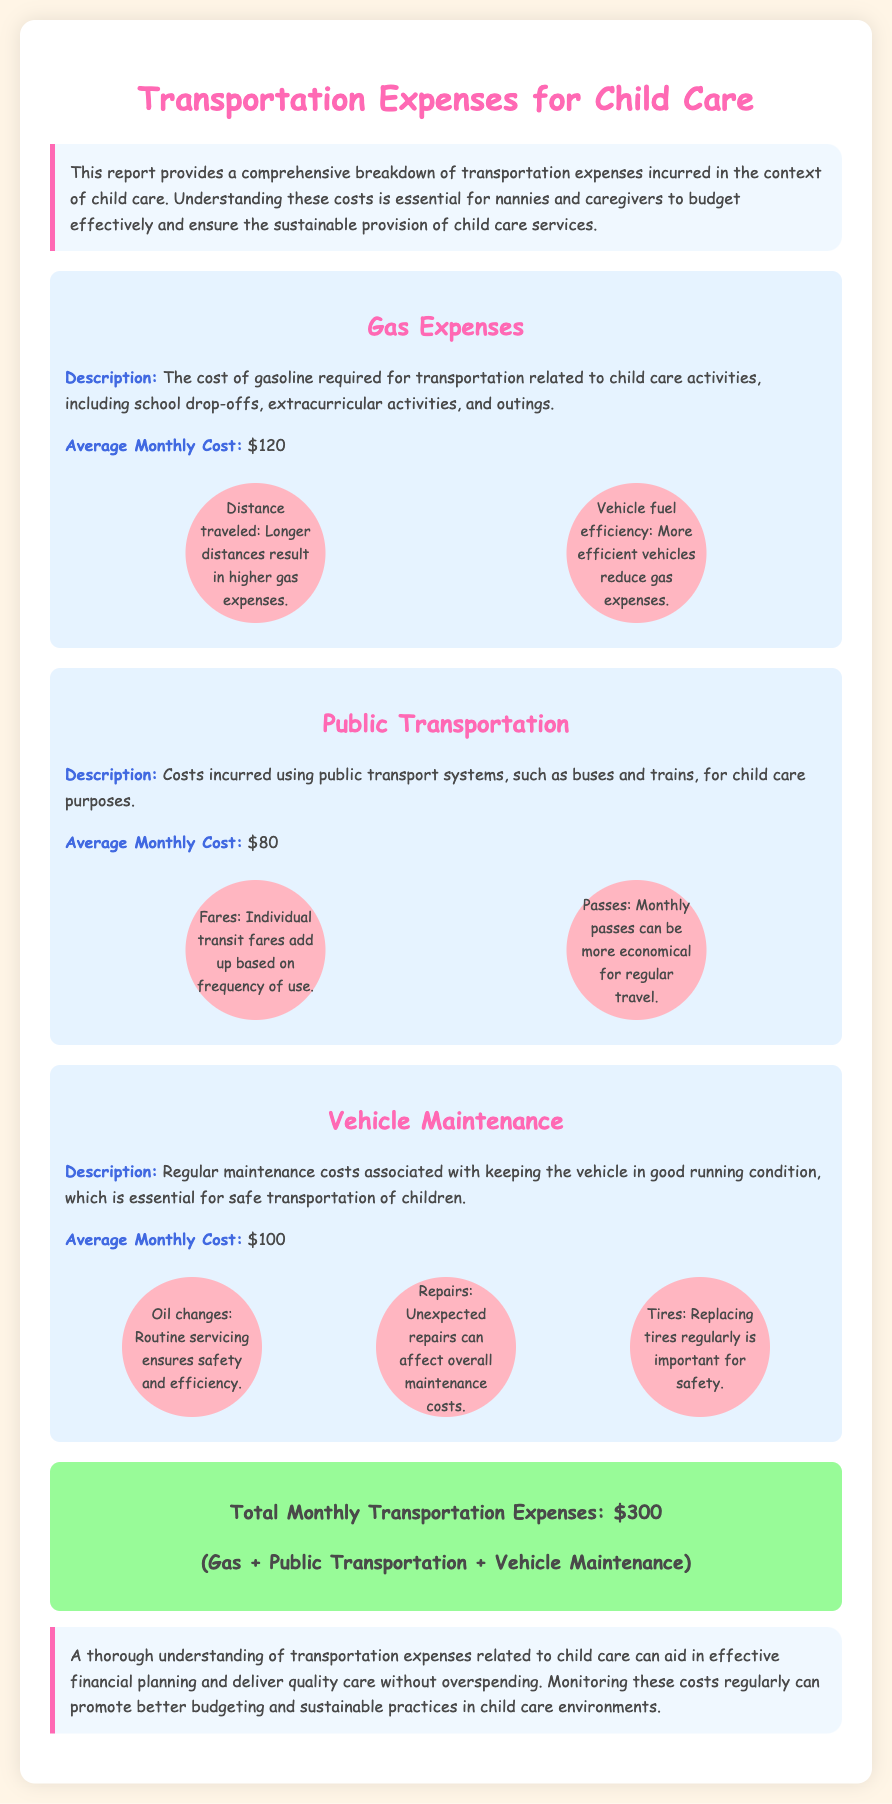What is the average monthly cost for gas expenses? The average monthly cost for gas expenses is indicated in the report as $120.
Answer: $120 What are the two factors influencing gas expenses? The report mentions "Distance traveled" and "Vehicle fuel efficiency" as the two factors that influence gas expenses.
Answer: Distance traveled, Vehicle fuel efficiency What is the total monthly transportation expense? The total monthly transportation expense is calculated by adding gas, public transportation, and vehicle maintenance costs, which equals $300.
Answer: $300 What is the average monthly cost for public transportation? The average monthly cost specified for public transportation is $80.
Answer: $80 What is the average monthly cost for vehicle maintenance? In the document, the average monthly cost for vehicle maintenance is given as $100.
Answer: $100 What is one reason why oil changes are important? The report states that oil changes are important for "Routine servicing ensures safety and efficiency."
Answer: Safety and efficiency What type of document is this? The nature of the document is a financial report that provides a breakdown of transportation expenses related to child care.
Answer: Financial report What background color is used for the conclusion section? The background color used for the conclusion section is light blue, specified as #F0F8FF in the style.
Answer: Light blue What is one advantage of using monthly passes for public transportation? The report notes that "Monthly passes can be more economical for regular travel," indicating their advantage.
Answer: More economical 